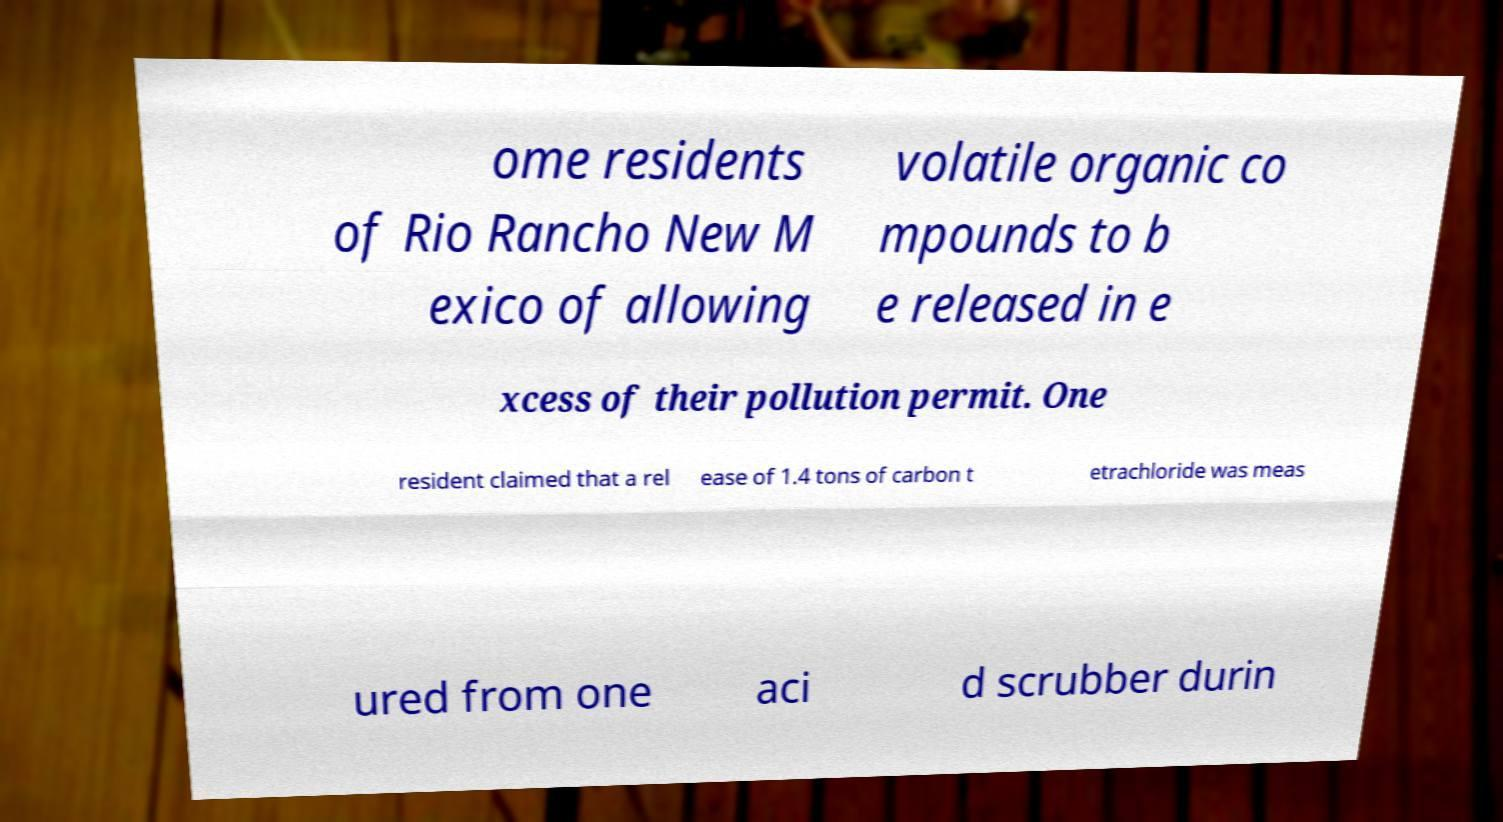What messages or text are displayed in this image? I need them in a readable, typed format. ome residents of Rio Rancho New M exico of allowing volatile organic co mpounds to b e released in e xcess of their pollution permit. One resident claimed that a rel ease of 1.4 tons of carbon t etrachloride was meas ured from one aci d scrubber durin 